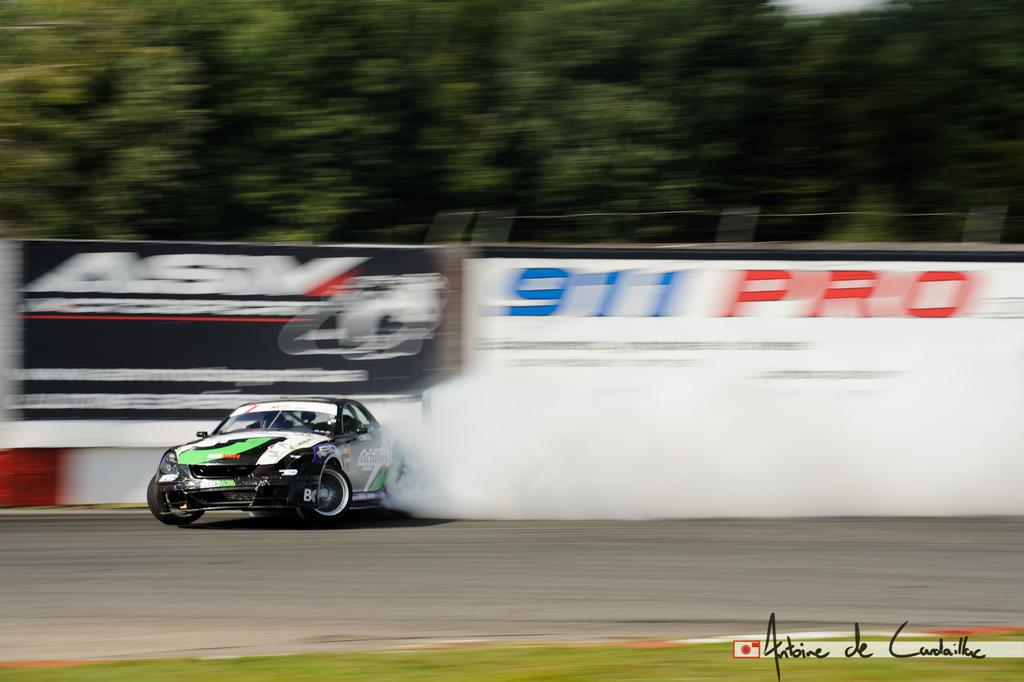What is the main subject of the image? There is a car in the image. Where is the car located? The car is on the road. What can be seen in the background of the image? There are boards and trees in the background of the image. Is there any visible smoke in the image? Yes, there is smoke visible in the image. What type of egg is being served for breakfast in the image? There is no reference to breakfast or eggs in the image; it features a car on the road with smoke and a background of boards and trees. 